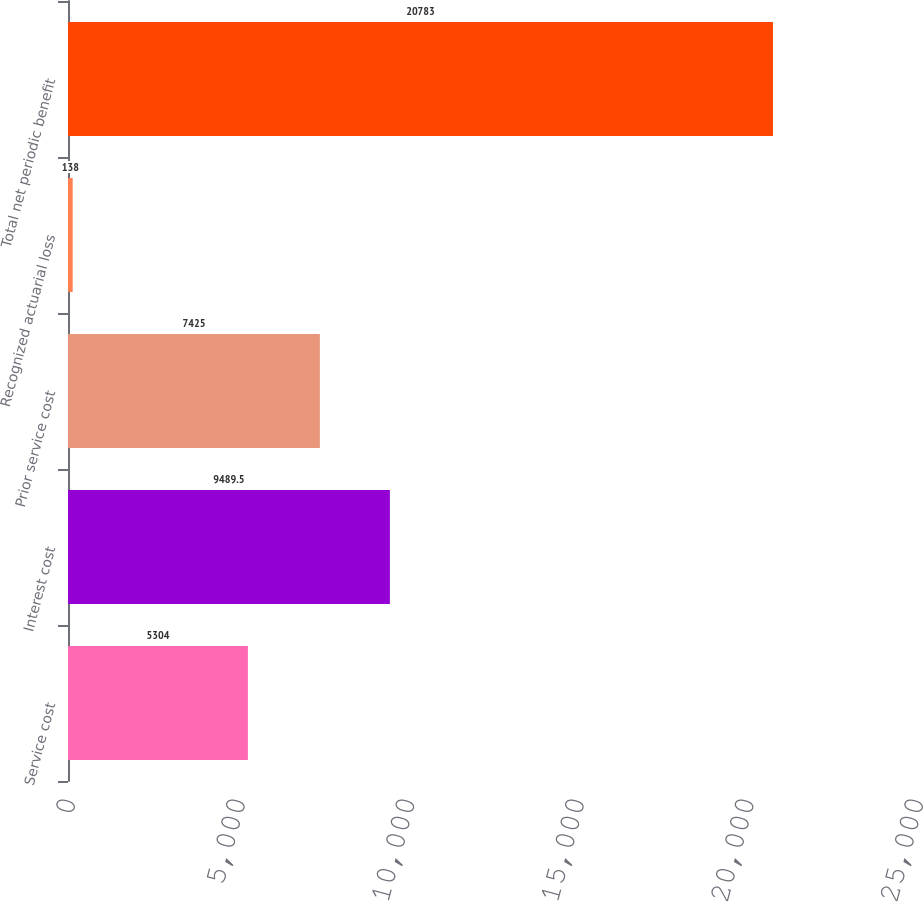<chart> <loc_0><loc_0><loc_500><loc_500><bar_chart><fcel>Service cost<fcel>Interest cost<fcel>Prior service cost<fcel>Recognized actuarial loss<fcel>Total net periodic benefit<nl><fcel>5304<fcel>9489.5<fcel>7425<fcel>138<fcel>20783<nl></chart> 